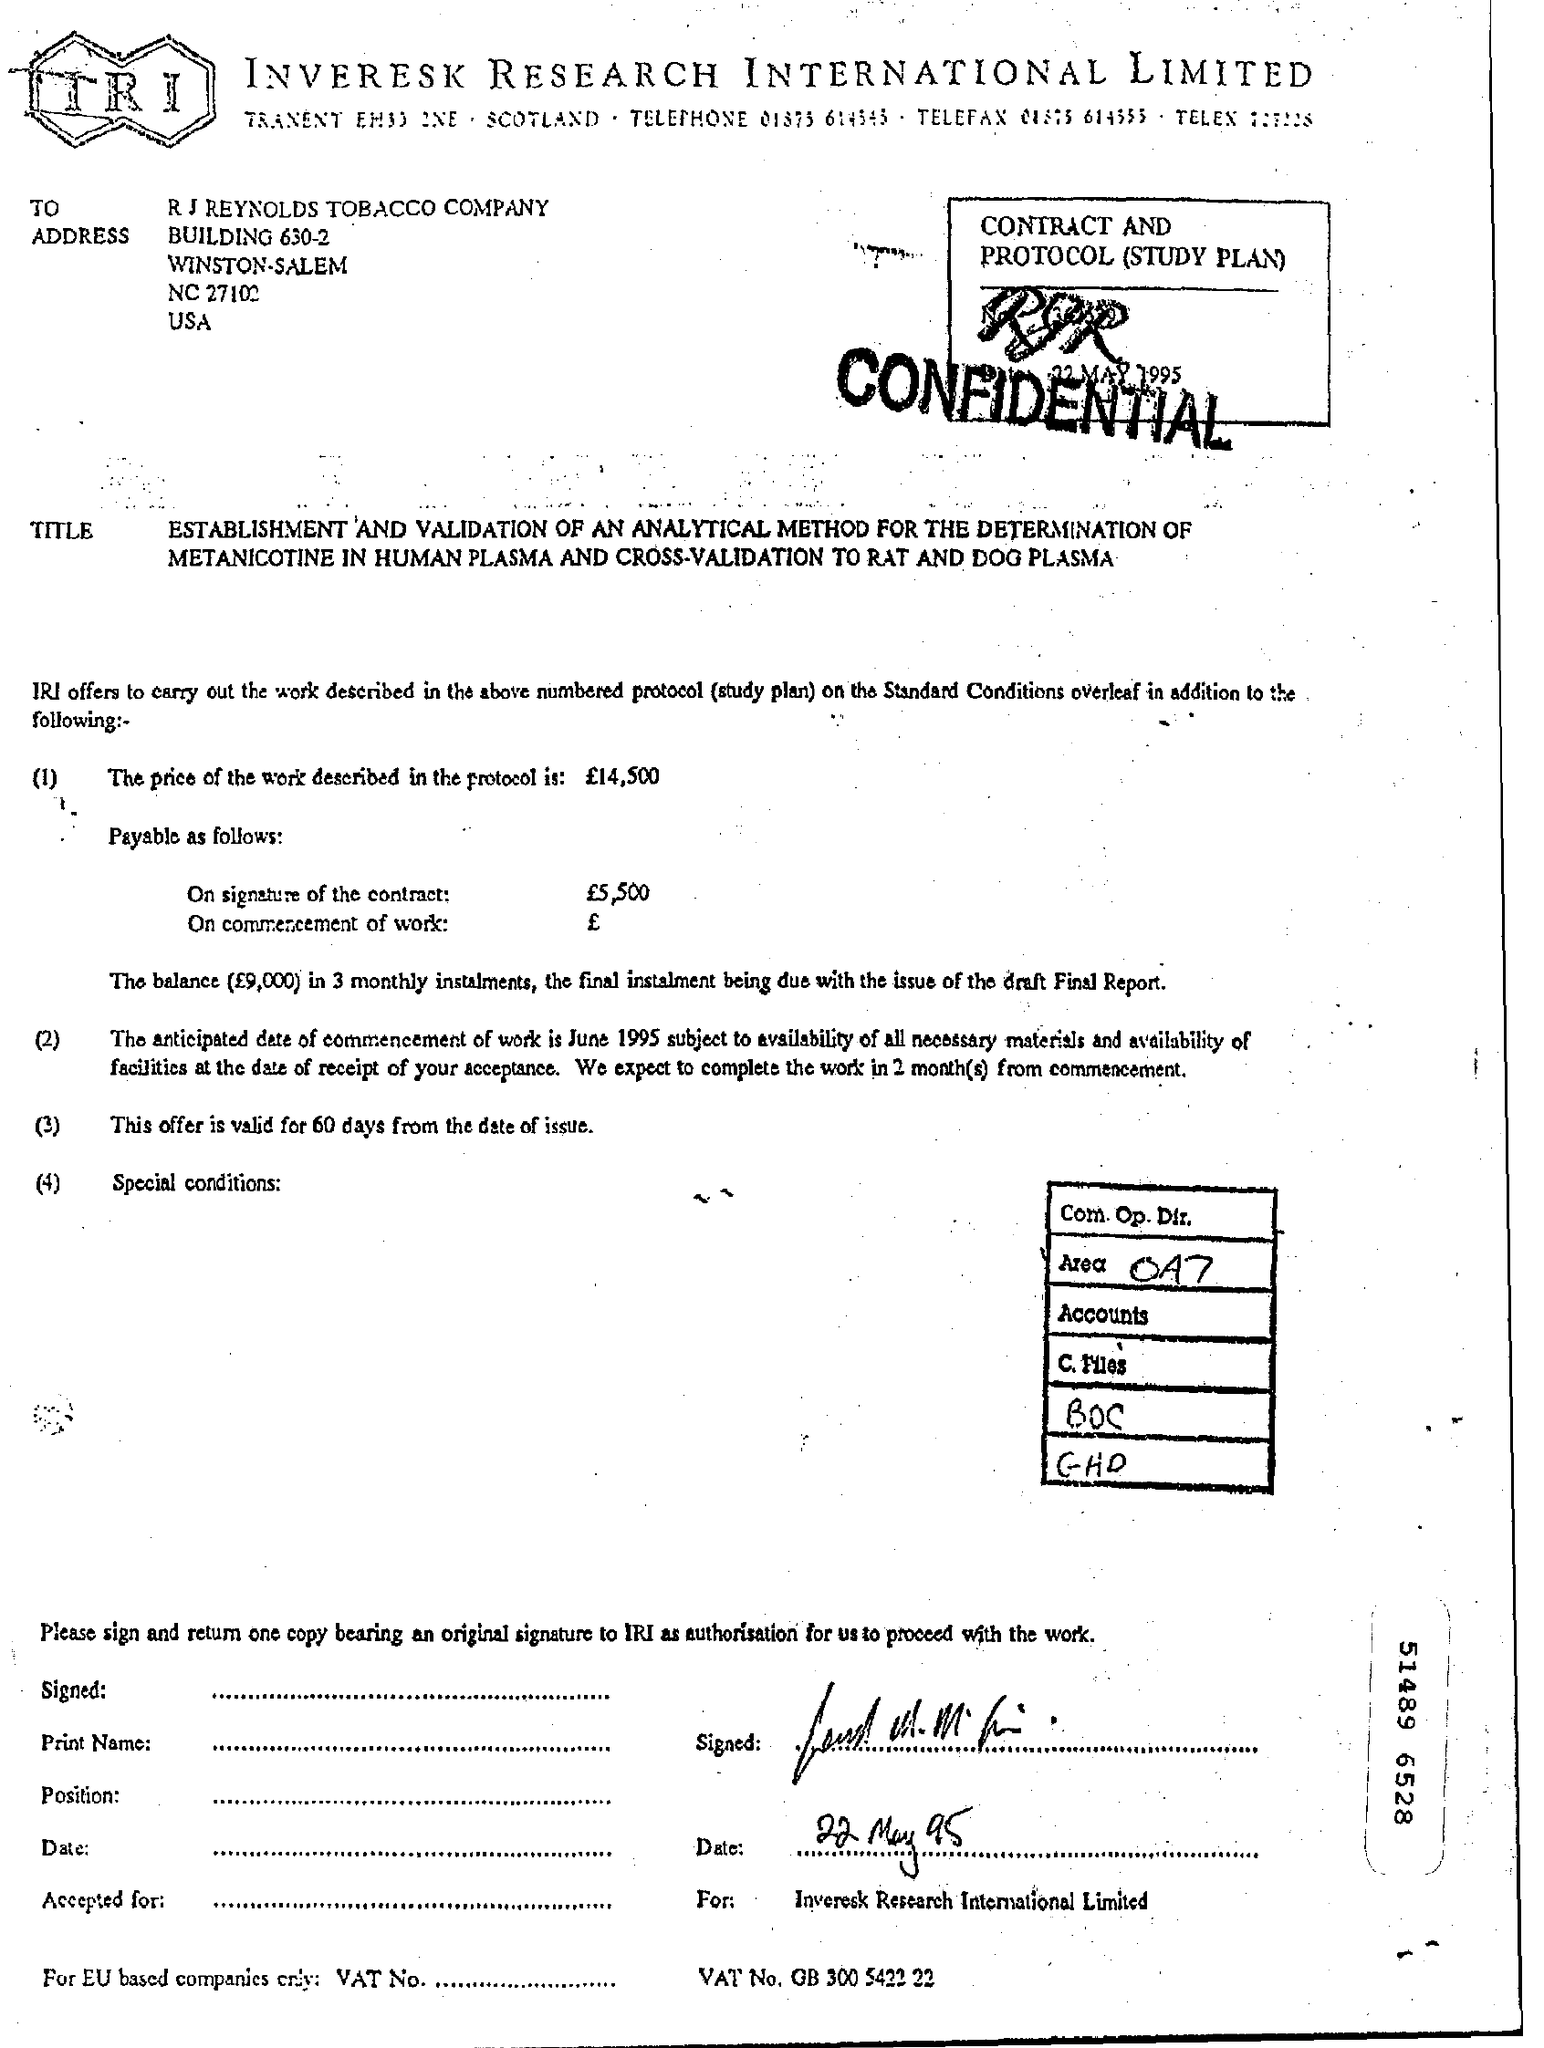Outline some significant characteristics in this image. The offer is valid for 60 days from the date of issue. This fax is addressed to the R.J. Reynolds Tobacco Company. 